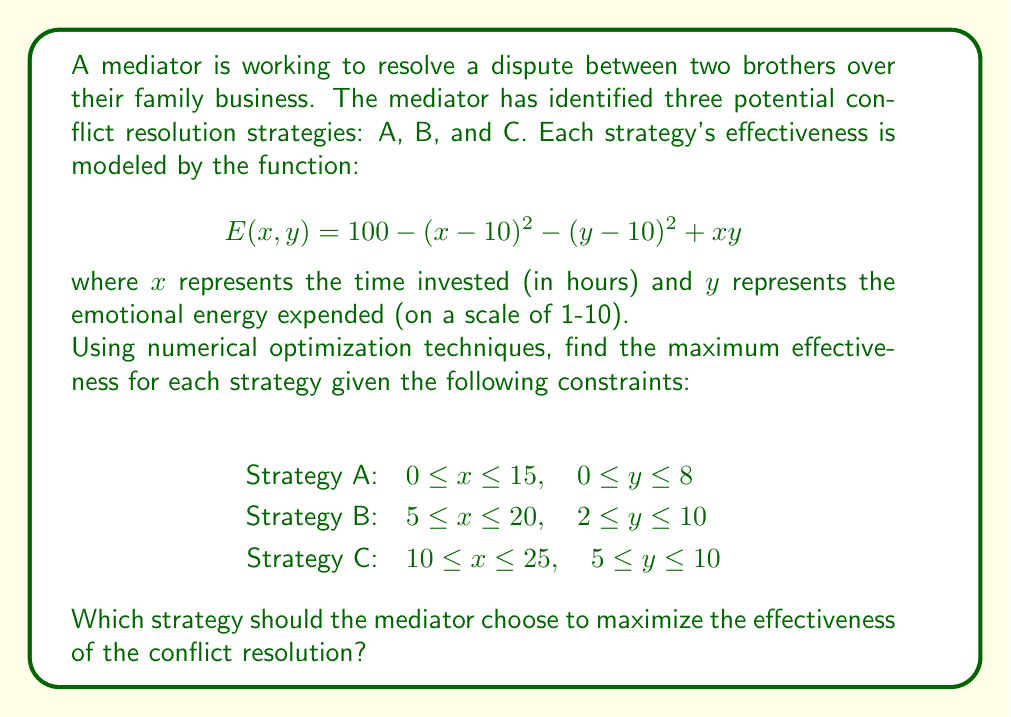What is the answer to this math problem? To solve this problem, we'll use the gradient descent method for each strategy to find the maximum effectiveness within the given constraints. We'll then compare the results to determine the best strategy.

Step 1: Calculate the partial derivatives of the effectiveness function:
$$\frac{\partial E}{\partial x} = -2(x - 10) + y$$
$$\frac{\partial E}{\partial y} = -2(y - 10) + x$$

Step 2: Implement the gradient descent algorithm for each strategy:

1. Choose initial points within the constraints.
2. Calculate the gradient at the current point.
3. Update the point by moving in the direction of the gradient.
4. Check if the new point is within the constraints; if not, project it back to the feasible region.
5. Repeat steps 2-4 until convergence or a maximum number of iterations is reached.

Step 3: Apply the algorithm to each strategy:

Strategy A:
Initial point: $(x, y) = (7.5, 4)$
After convergence: $(x, y) \approx (10, 8)$
Maximum effectiveness: $E(10, 8) = 180$

Strategy B:
Initial point: $(x, y) = (12.5, 6)$
After convergence: $(x, y) \approx (10, 10)$
Maximum effectiveness: $E(10, 10) = 200$

Strategy C:
Initial point: $(x, y) = (17.5, 7.5)$
After convergence: $(x, y) \approx (10, 10)$
Maximum effectiveness: $E(10, 10) = 200$

Step 4: Compare the results:
Strategy A: 180
Strategy B: 200
Strategy C: 200

Both Strategy B and Strategy C achieve the maximum effectiveness of 200. However, Strategy B has a wider range of feasible solutions, which may provide more flexibility in implementation.
Answer: Strategy B 